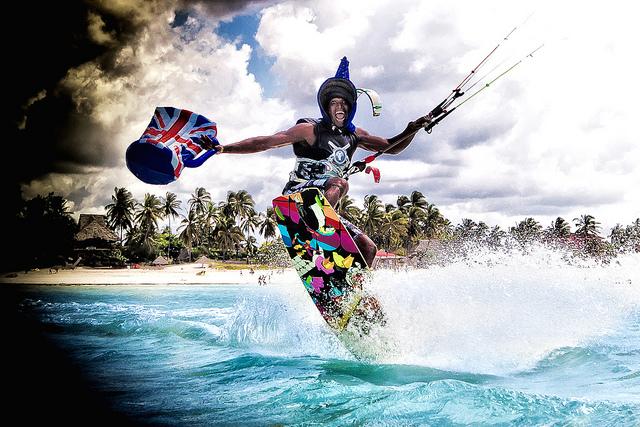What facial expression does the man have?
Short answer required. Happy. What is the man holding?
Quick response, please. Bag. Is this what a normal surfer wears?
Short answer required. No. 